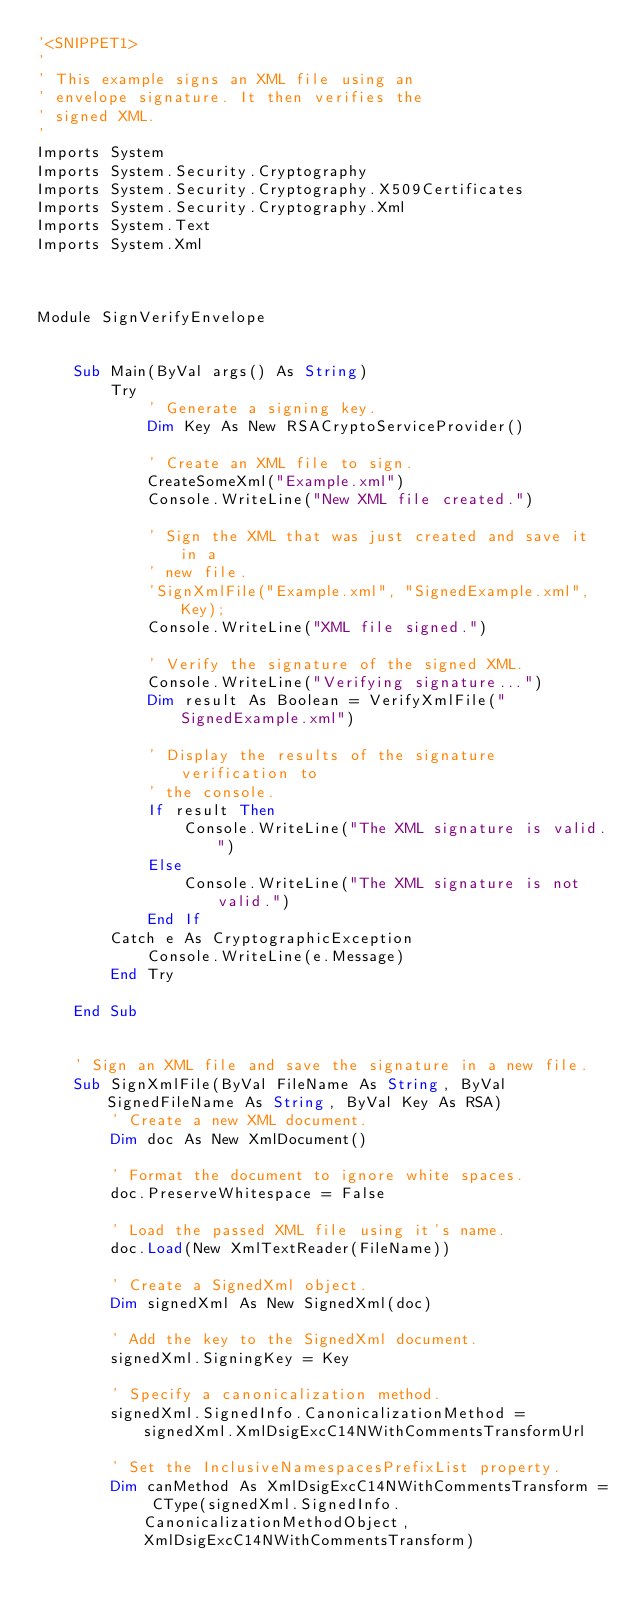Convert code to text. <code><loc_0><loc_0><loc_500><loc_500><_VisualBasic_>'<SNIPPET1>
'
' This example signs an XML file using an
' envelope signature. It then verifies the 
' signed XML.
'
Imports System
Imports System.Security.Cryptography
Imports System.Security.Cryptography.X509Certificates
Imports System.Security.Cryptography.Xml
Imports System.Text
Imports System.Xml



Module SignVerifyEnvelope


    Sub Main(ByVal args() As String)
        Try
            ' Generate a signing key.
            Dim Key As New RSACryptoServiceProvider()

            ' Create an XML file to sign.
            CreateSomeXml("Example.xml")
            Console.WriteLine("New XML file created.")

            ' Sign the XML that was just created and save it in a 
            ' new file.
            'SignXmlFile("Example.xml", "SignedExample.xml", Key);
            Console.WriteLine("XML file signed.")

            ' Verify the signature of the signed XML.
            Console.WriteLine("Verifying signature...")
            Dim result As Boolean = VerifyXmlFile("SignedExample.xml")

            ' Display the results of the signature verification to 
            ' the console.
            If result Then
                Console.WriteLine("The XML signature is valid.")
            Else
                Console.WriteLine("The XML signature is not valid.")
            End If
        Catch e As CryptographicException
            Console.WriteLine(e.Message)
        End Try

    End Sub


    ' Sign an XML file and save the signature in a new file.
    Sub SignXmlFile(ByVal FileName As String, ByVal SignedFileName As String, ByVal Key As RSA)
        ' Create a new XML document.
        Dim doc As New XmlDocument()

        ' Format the document to ignore white spaces.
        doc.PreserveWhitespace = False

        ' Load the passed XML file using it's name.
        doc.Load(New XmlTextReader(FileName))

        ' Create a SignedXml object.
        Dim signedXml As New SignedXml(doc)

        ' Add the key to the SignedXml document. 
        signedXml.SigningKey = Key

        ' Specify a canonicalization method.
        signedXml.SignedInfo.CanonicalizationMethod = signedXml.XmlDsigExcC14NWithCommentsTransformUrl

        ' Set the InclusiveNamespacesPrefixList property.
        Dim canMethod As XmlDsigExcC14NWithCommentsTransform = CType(signedXml.SignedInfo.CanonicalizationMethodObject, XmlDsigExcC14NWithCommentsTransform)</code> 